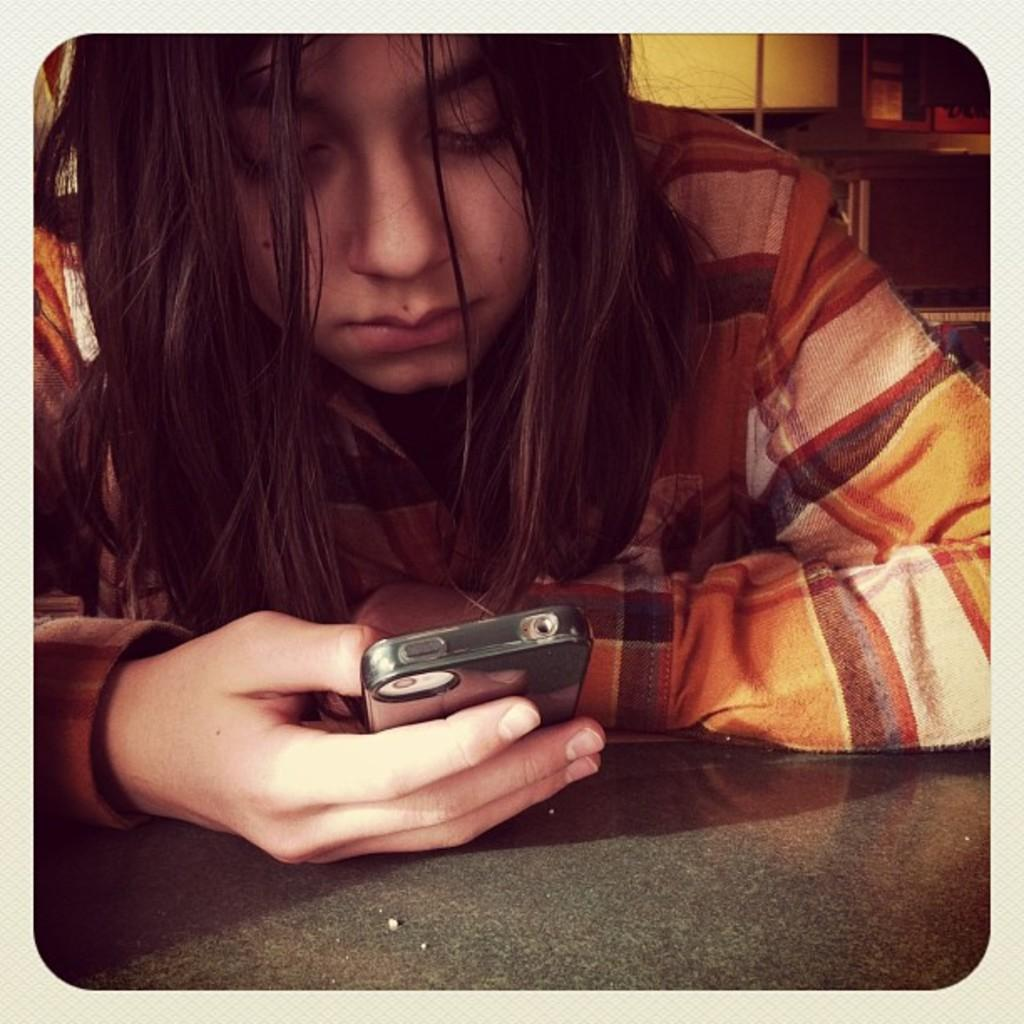Who is the main subject in the image? There is a girl in the image. What is the girl doing in the image? The girl is looking at a mobile phone. How is the girl dressed in the image? The girl is wearing a good dress. What is the girl's reaction to the cabbage in the image? There is no cabbage present in the image, so it is not possible to determine the girl's reaction to it. 